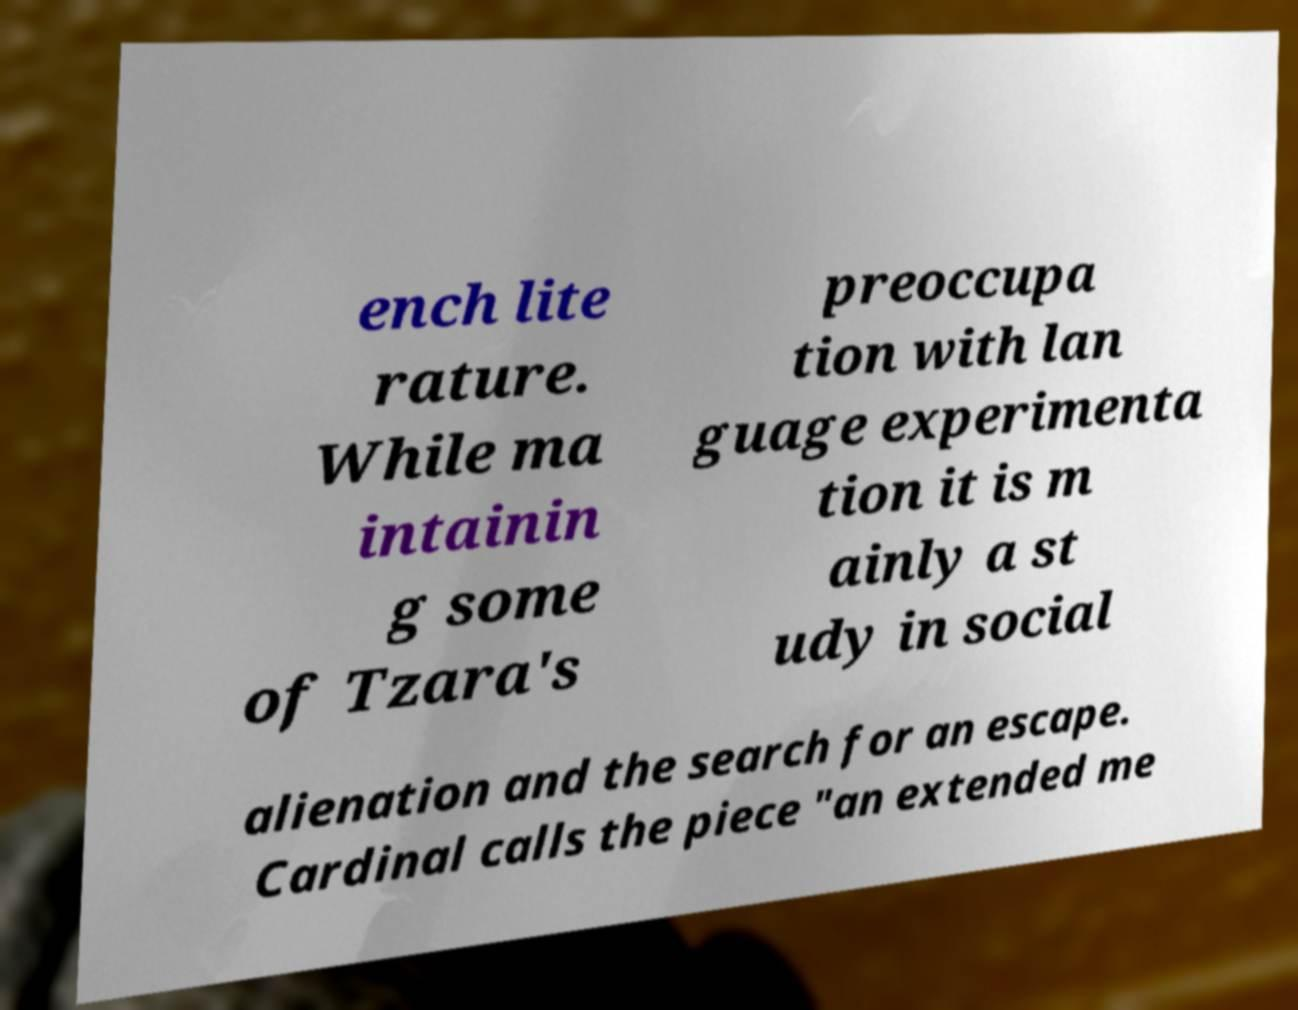I need the written content from this picture converted into text. Can you do that? ench lite rature. While ma intainin g some of Tzara's preoccupa tion with lan guage experimenta tion it is m ainly a st udy in social alienation and the search for an escape. Cardinal calls the piece "an extended me 